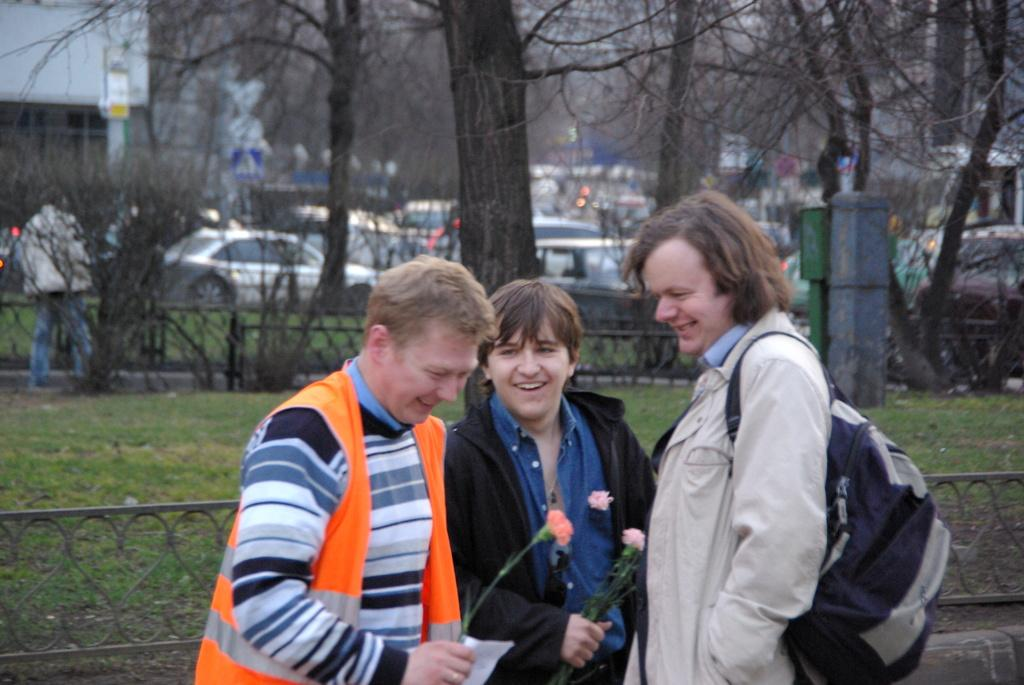How many people are present in the image? There are three people standing in the image. What can be seen in the background of the image? There are trees, cars, and buildings in the background of the image. What type of seed is being planted by the bear in the image? There is no bear present in the image, and therefore no seed planting can be observed. 